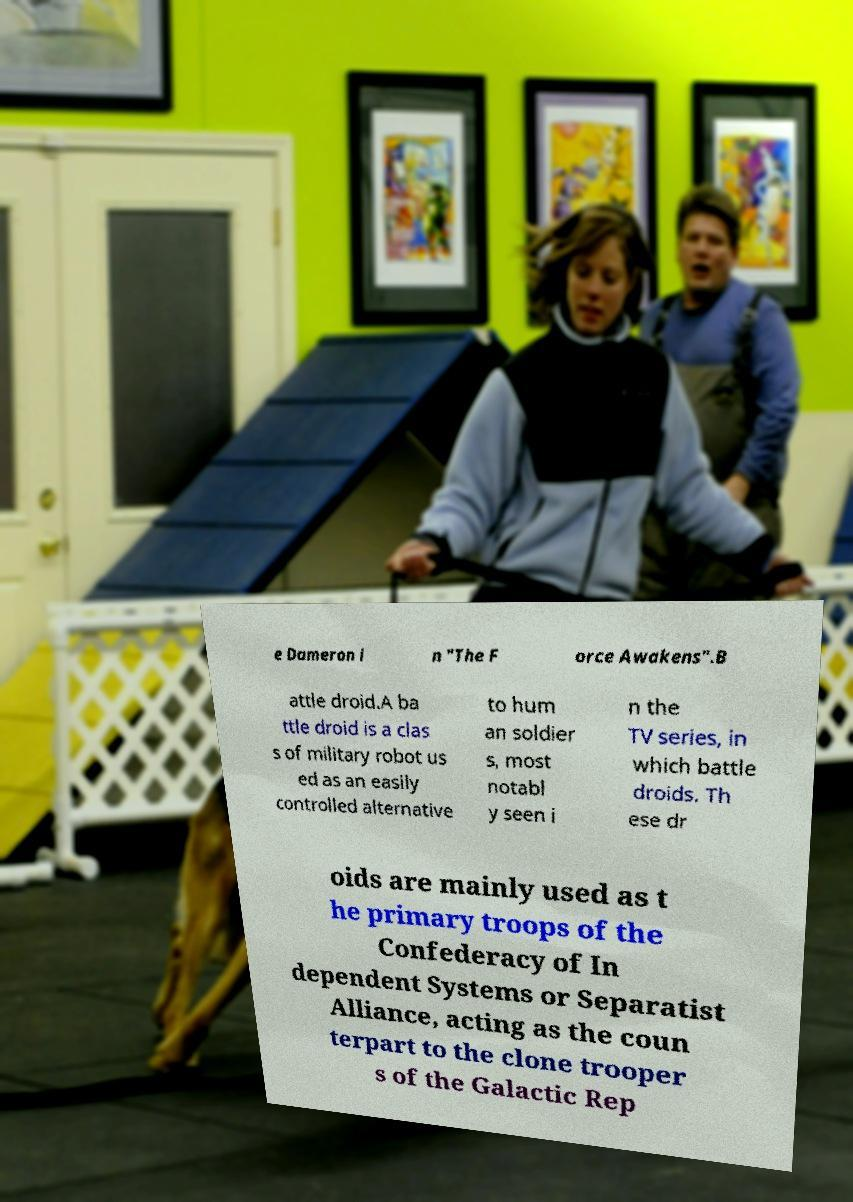Can you read and provide the text displayed in the image?This photo seems to have some interesting text. Can you extract and type it out for me? e Dameron i n "The F orce Awakens".B attle droid.A ba ttle droid is a clas s of military robot us ed as an easily controlled alternative to hum an soldier s, most notabl y seen i n the TV series, in which battle droids. Th ese dr oids are mainly used as t he primary troops of the Confederacy of In dependent Systems or Separatist Alliance, acting as the coun terpart to the clone trooper s of the Galactic Rep 